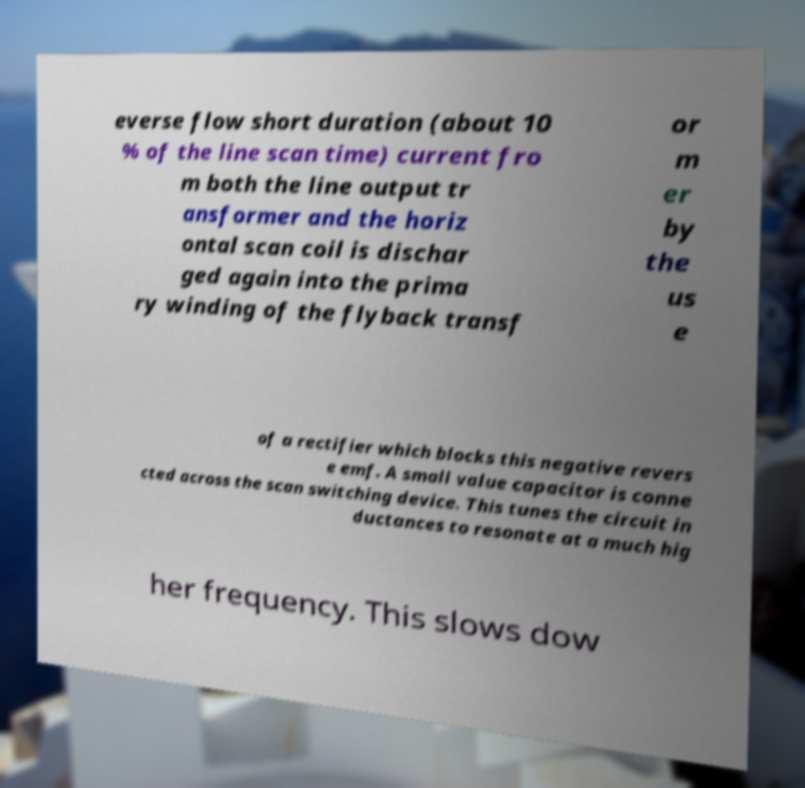Please read and relay the text visible in this image. What does it say? everse flow short duration (about 10 % of the line scan time) current fro m both the line output tr ansformer and the horiz ontal scan coil is dischar ged again into the prima ry winding of the flyback transf or m er by the us e of a rectifier which blocks this negative revers e emf. A small value capacitor is conne cted across the scan switching device. This tunes the circuit in ductances to resonate at a much hig her frequency. This slows dow 